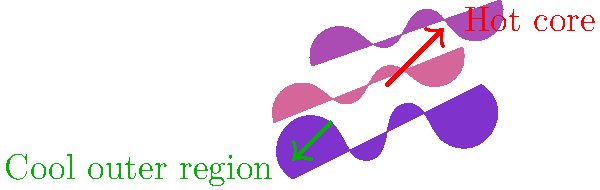In the colorful cloud-like graphic representing a nebula, what does the structure suggest about the temperature distribution, and how might this relate to sound design principles in synthesizer patches? To answer this question, let's break down the structure of the nebula and relate it to sound design principles:

1. Core structure: The red arrow points to a "Hot core" in the center of the nebula. In astronomy, this indicates a region of high energy and temperature.

2. Outer regions: The green arrow points to a "Cool outer region" at the periphery of the nebula. This suggests a temperature gradient from the center to the edges.

3. Color gradient: The cloud-like structures show a color transition from blue (cool) to red (hot), reinforcing the temperature distribution.

4. Relating to synthesizer sound design:
   a) Temperature gradient ⇔ Frequency spectrum:
      - Hot core (high energy) ⇔ High frequencies
      - Cool outer region (low energy) ⇔ Low frequencies
   
   b) Structure analogy in sound design:
      - Core ⇔ Fundamental frequency or carrier in FM synthesis
      - Outer regions ⇔ Harmonics or modulator in FM synthesis
   
   c) Color gradient ⇔ Timbre evolution:
      - Could represent filter sweeps or spectral changes over time

5. Potential sound design application:
   - Create a patch that starts with high-frequency content (representing the hot core)
   - Gradually introduce lower frequencies and reduce high frequencies (mimicking the transition to cooler outer regions)
   - Use FM synthesis or subtractive synthesis with filter modulation to achieve this effect

This structure suggests a sound design approach that moves from bright, energetic tones to darker, more subdued tones, mirroring the nebula's temperature distribution.
Answer: Temperature gradient from hot core to cool outer regions, analogous to frequency spectrum and timbre evolution in synthesizer sound design. 